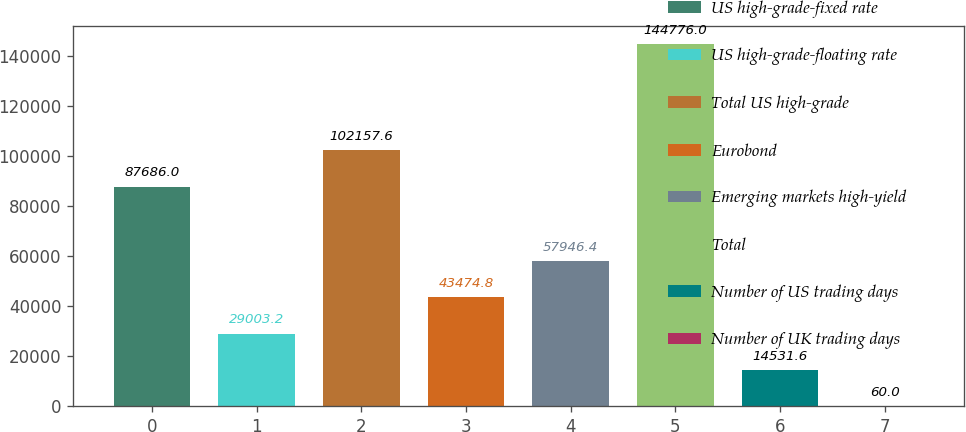Convert chart. <chart><loc_0><loc_0><loc_500><loc_500><bar_chart><fcel>US high-grade-fixed rate<fcel>US high-grade-floating rate<fcel>Total US high-grade<fcel>Eurobond<fcel>Emerging markets high-yield<fcel>Total<fcel>Number of US trading days<fcel>Number of UK trading days<nl><fcel>87686<fcel>29003.2<fcel>102158<fcel>43474.8<fcel>57946.4<fcel>144776<fcel>14531.6<fcel>60<nl></chart> 